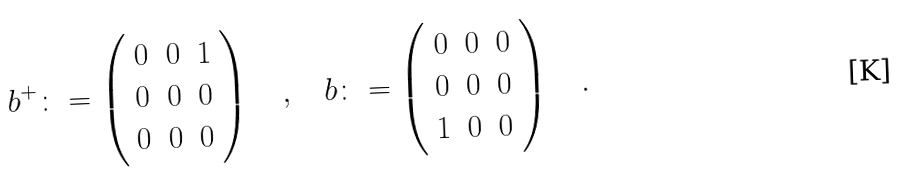<formula> <loc_0><loc_0><loc_500><loc_500>b ^ { + } \colon = \left ( \begin{array} { c c c } 0 & 0 & 1 \\ 0 & 0 & 0 \\ 0 & 0 & 0 \\ \end{array} \right ) \quad , \quad b \colon = \left ( \begin{array} { c c c } 0 & 0 & 0 \\ 0 & 0 & 0 \\ 1 & 0 & 0 \\ \end{array} \right ) \quad .</formula> 